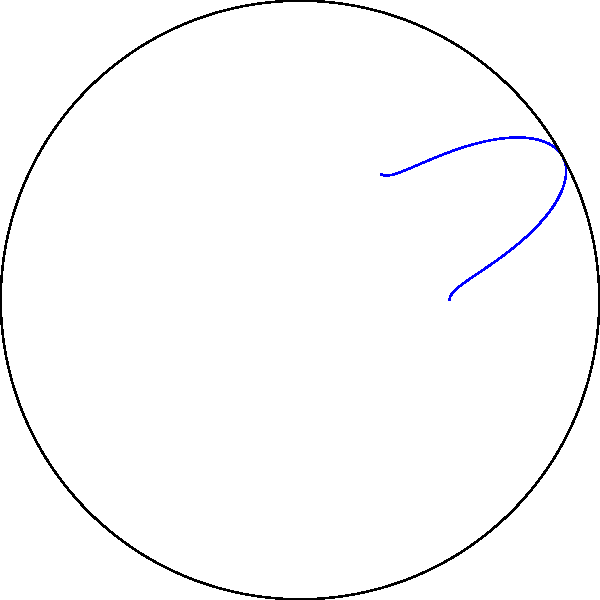An international solar energy project requires optimizing solar panel placement using sun path diagrams. The diagram shows the sun's path on a specific day in polar coordinates, where the radial coordinate represents the sun's altitude (90° at zenith, 0° at horizon), and the angular coordinate represents the azimuth (0° at North, increasing clockwise). Given that the project aims to maximize energy capture throughout the day, at what approximate azimuth and altitude should the solar panels be oriented for optimal placement? To determine the optimal solar panel placement, we need to analyze the sun path diagram and find the point that best represents the average position of the sun throughout the day. Here's a step-by-step approach:

1. Observe that the sun path forms an arc from East to West (left to right in the diagram).

2. The highest point of the arc represents solar noon, where the sun reaches its maximum altitude for the day.

3. The optimal placement should balance morning and afternoon sun exposure while maximizing altitude.

4. Visually, this point would be near the center of the arc, slightly before solar noon to account for higher morning efficiency of solar panels.

5. Using the polar grid:
   - The azimuth appears to be around 120° from North (30° east of South).
   - The altitude is approximately 60° above the horizon.

6. The red dot on the diagram indicates this optimal point.

7. Converting to the coordinate system used in the question:
   - Azimuth: 180° - 120° = 60° (measuring from South and positive towards East)
   - Altitude: Remains 60°

Therefore, the optimal orientation for the solar panels would be at an azimuth of approximately 60° East of South and an altitude of about 60° above the horizon.
Answer: Azimuth: 60° East of South, Altitude: 60° 